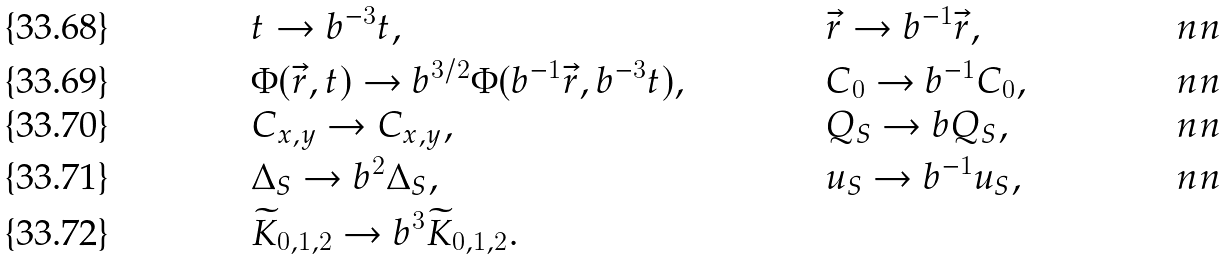<formula> <loc_0><loc_0><loc_500><loc_500>& t \rightarrow b ^ { - 3 } t , & & \vec { r } \rightarrow b ^ { - 1 } \vec { r } , & \ n n \\ & \Phi ( \vec { r } , t ) \rightarrow b ^ { 3 / 2 } \Phi ( b ^ { - 1 } \vec { r } , b ^ { - 3 } t ) , & & C _ { 0 } \rightarrow b ^ { - 1 } C _ { 0 } , & \ n n \\ & C _ { x , y } \rightarrow C _ { x , y } , & & Q _ { S } \rightarrow b Q _ { S } , & \ n n \\ & \Delta _ { S } \rightarrow b ^ { 2 } \Delta _ { S } , & & u _ { S } \rightarrow b ^ { - 1 } u _ { S } , & \ n n \\ & \widetilde { K } _ { 0 , 1 , 2 } \rightarrow b ^ { 3 } \widetilde { K } _ { 0 , 1 , 2 } . & & &</formula> 